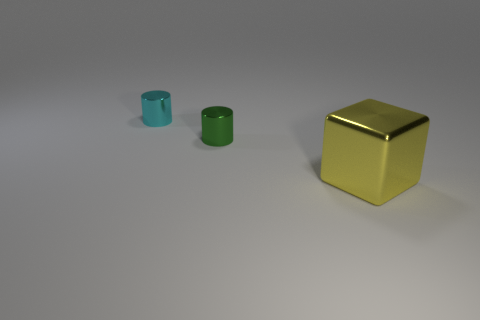Add 3 big cyan matte cubes. How many objects exist? 6 Subtract all cylinders. How many objects are left? 1 Add 2 green cylinders. How many green cylinders exist? 3 Subtract 0 blue balls. How many objects are left? 3 Subtract all large metallic things. Subtract all large yellow blocks. How many objects are left? 1 Add 2 shiny cubes. How many shiny cubes are left? 3 